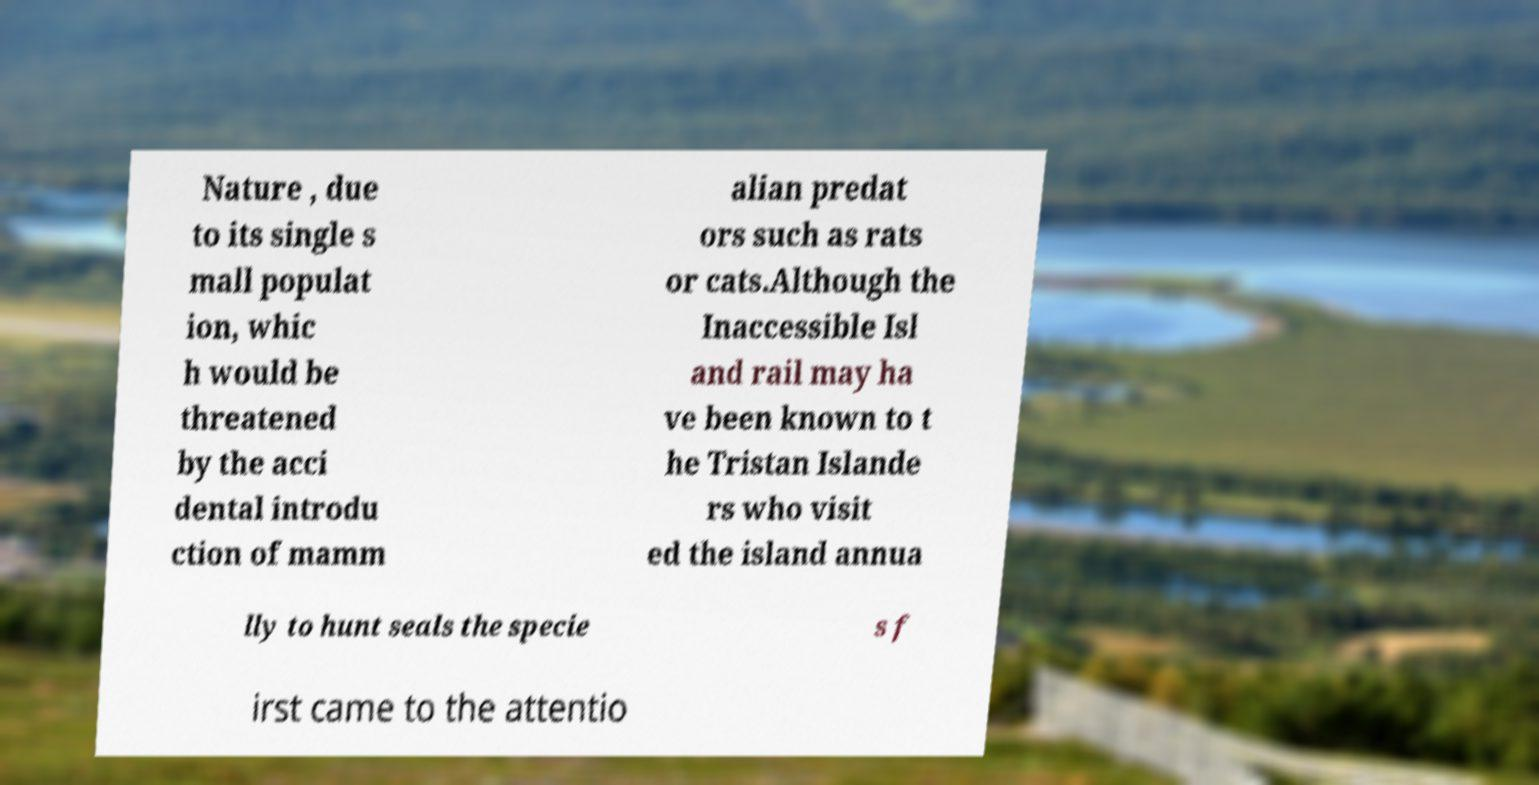I need the written content from this picture converted into text. Can you do that? Nature , due to its single s mall populat ion, whic h would be threatened by the acci dental introdu ction of mamm alian predat ors such as rats or cats.Although the Inaccessible Isl and rail may ha ve been known to t he Tristan Islande rs who visit ed the island annua lly to hunt seals the specie s f irst came to the attentio 